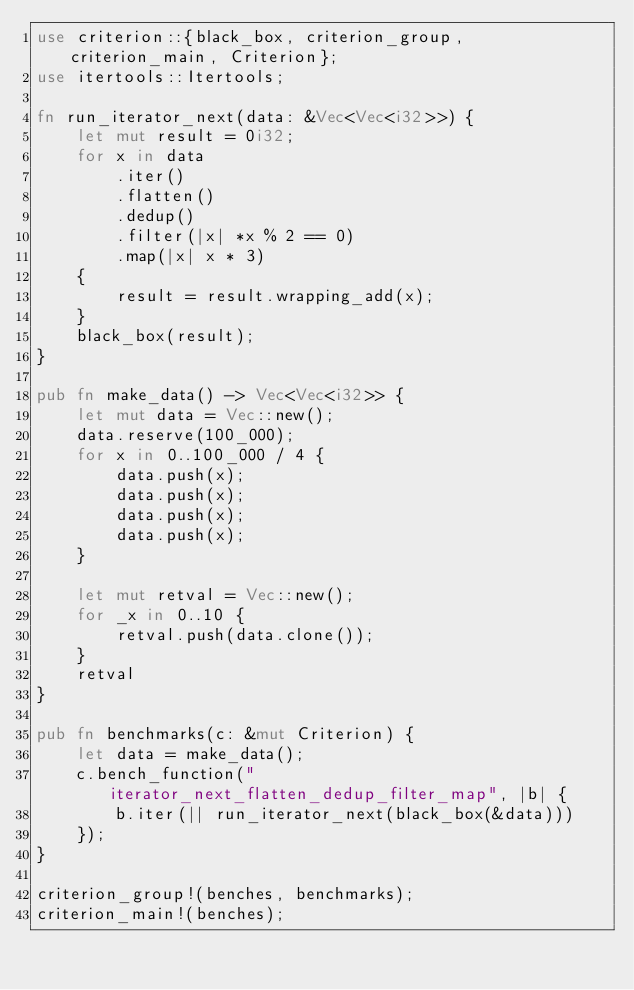Convert code to text. <code><loc_0><loc_0><loc_500><loc_500><_Rust_>use criterion::{black_box, criterion_group, criterion_main, Criterion};
use itertools::Itertools;

fn run_iterator_next(data: &Vec<Vec<i32>>) {
    let mut result = 0i32;
    for x in data
        .iter()
        .flatten()
        .dedup()
        .filter(|x| *x % 2 == 0)
        .map(|x| x * 3)
    {
        result = result.wrapping_add(x);
    }
    black_box(result);
}

pub fn make_data() -> Vec<Vec<i32>> {
    let mut data = Vec::new();
    data.reserve(100_000);
    for x in 0..100_000 / 4 {
        data.push(x);
        data.push(x);
        data.push(x);
        data.push(x);
    }

    let mut retval = Vec::new();
    for _x in 0..10 {
        retval.push(data.clone());
    }
    retval
}

pub fn benchmarks(c: &mut Criterion) {
    let data = make_data();
    c.bench_function("iterator_next_flatten_dedup_filter_map", |b| {
        b.iter(|| run_iterator_next(black_box(&data)))
    });
}

criterion_group!(benches, benchmarks);
criterion_main!(benches);
</code> 